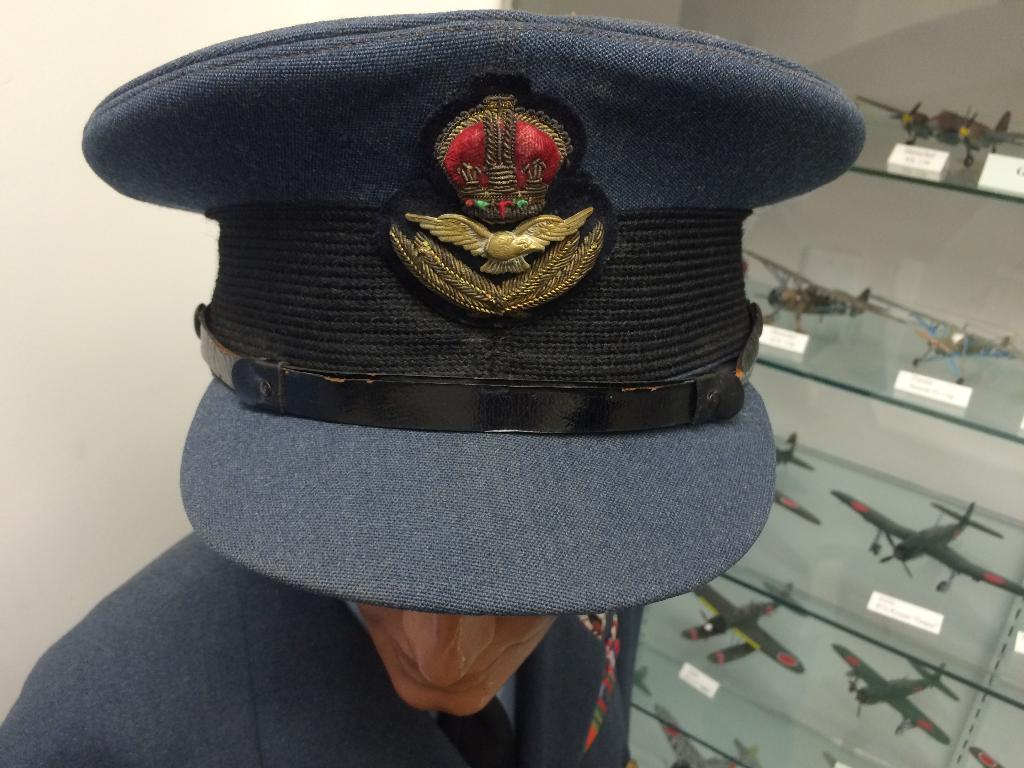What is the person in the image wearing on their head? The person in the image is wearing a cap. What type of furniture is present in the image? There are glass shelves in the image. What items can be seen on the glass shelves? There are toy aircrafts and boards on the glass shelves. What can be seen in the background of the image? There is a wall visible in the image. What type of food is being prepared on the wall in the image? There is no food preparation or cooking activity visible in the image, and the wall is not being used for that purpose. 